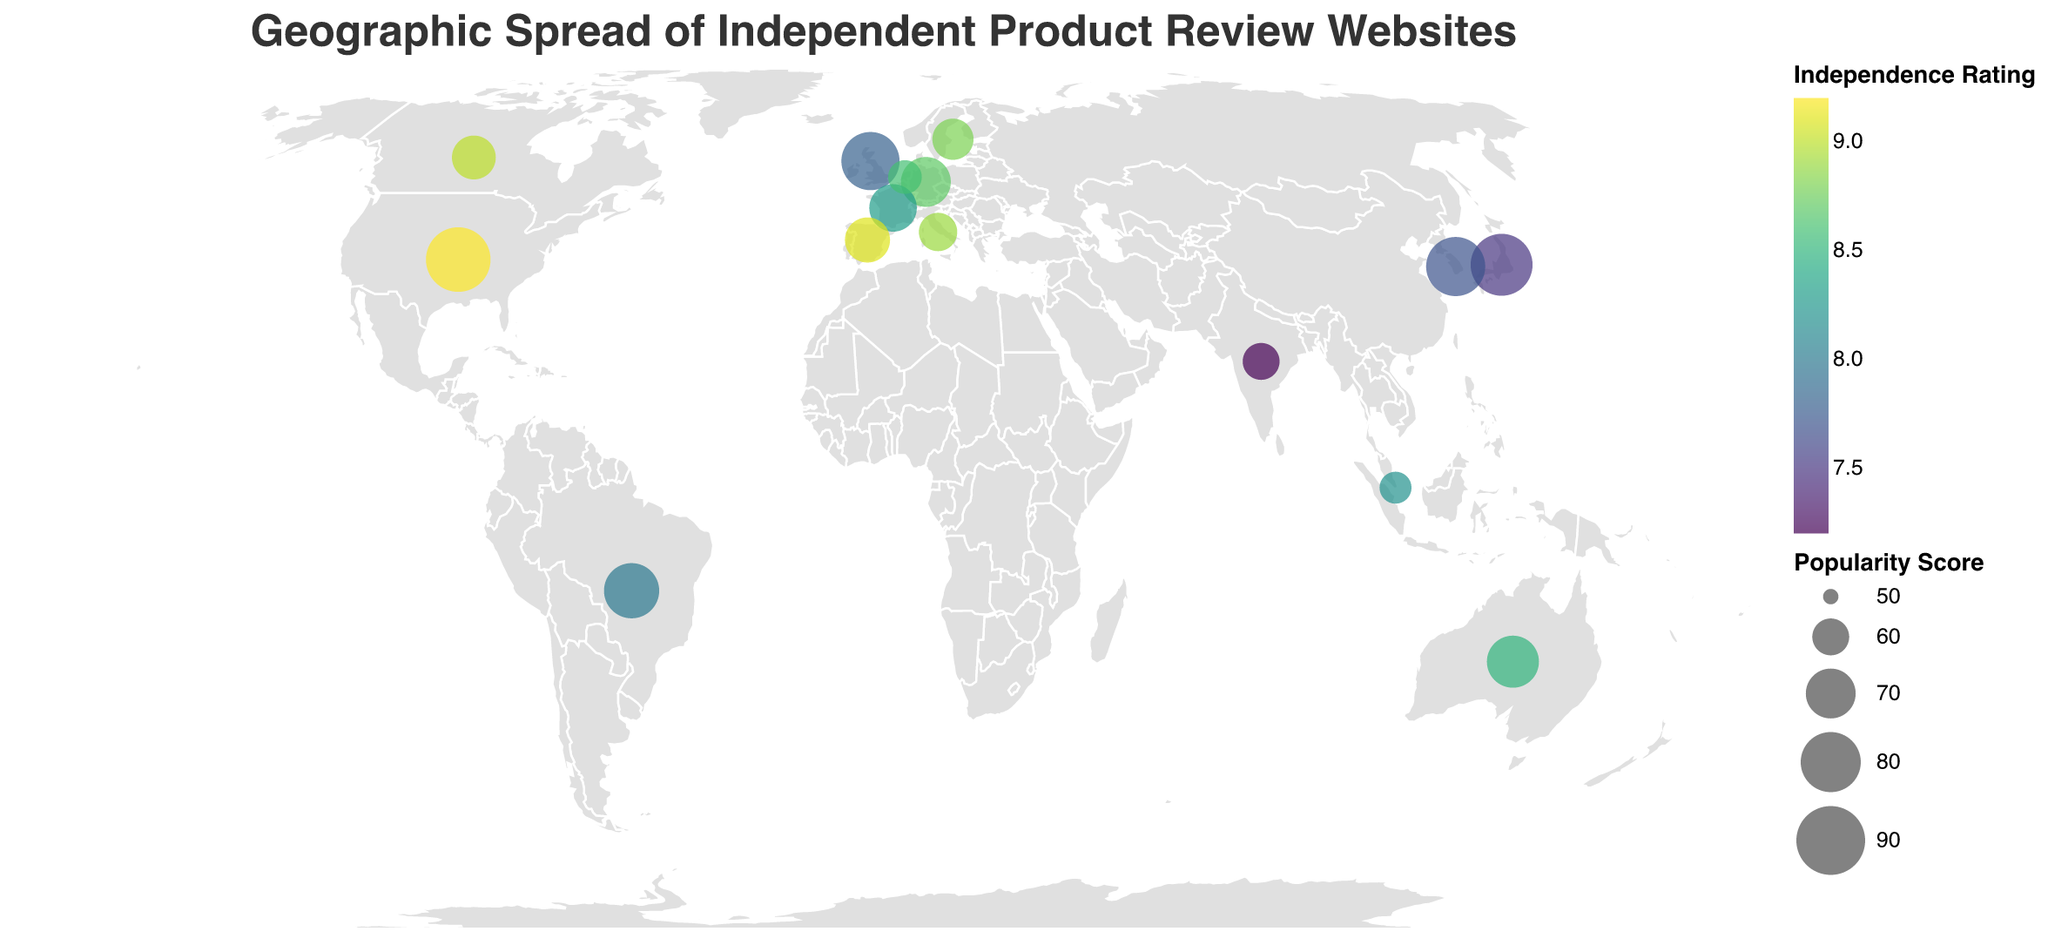What is the title of the figure? The title is displayed at the top of the figure and provides a summary of what the plot represents.
Answer: Geographic Spread of Independent Product Review Websites Which country has the highest popularity score for its product review website? The country with the largest circle represents the highest popularity score. In this case, the United States has the largest circle, indicating the highest score.
Answer: United States What is the color scheme used for the independence rating? The color scheme is indicated in the legend showing shades from light to dark. The color scale scheme used is "viridis," which ranges from yellow to dark green.
Answer: Viridis Which website in Asia has the highest independence rating? By looking at the data points located in Asia, we compare the independence ratings of websites. Kakaku.com in Japan has an independence rating of 7.5, MouthShut.com in India has a rating of 7.2, and Danawa.com in South Korea has a rating of 7.7. Danawa.com has the highest rating at 7.7.
Answer: Danawa.com What is the average popularity score of the websites in Europe? To calculate the average popularity score for Europe, we sum the popularity scores and divide by the number of data points. Europe has five websites: TrustPilot.com (78), TestBerichte.de (70), LesNumeriques.com (68), OCU.org (66), Altroconsumo.it (61), and Kieskeurig.nl (58). The sum is 78 + 70 + 68 + 66 + 61 + 58 = 401 and there are six data points. The average is 401/6 = 66.83.
Answer: 66.83 Which website has the highest independence rating? The website with the darkest circle represents the highest independence rating. In the figure, ConsumerReports.org in the United States has the darkest shade, indicating a rating of 9.2.
Answer: ConsumerReports.org Compare the popularity score and independence rating of ConsumerReports.org and TrustPilot.com. Which one scores higher in both categories? We need to compare both the popularity score and independence rating for each website. ConsumerReports.org has a popularity score of 85 and independence rating of 9.2 whereas TrustPilot.com has a popularity score of 78 and independence rating of 7.8. ConsumerReports.org scores higher in both categories.
Answer: ConsumerReports.org How many countries have an independence rating greater than 8? We count the data points where the independence rating is greater than 8. There are eight countries: United States, Australia, Canada, Germany, France, Sweden, Netherlands, and Italy.
Answer: 8 